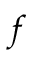Convert formula to latex. <formula><loc_0><loc_0><loc_500><loc_500>{ f }</formula> 